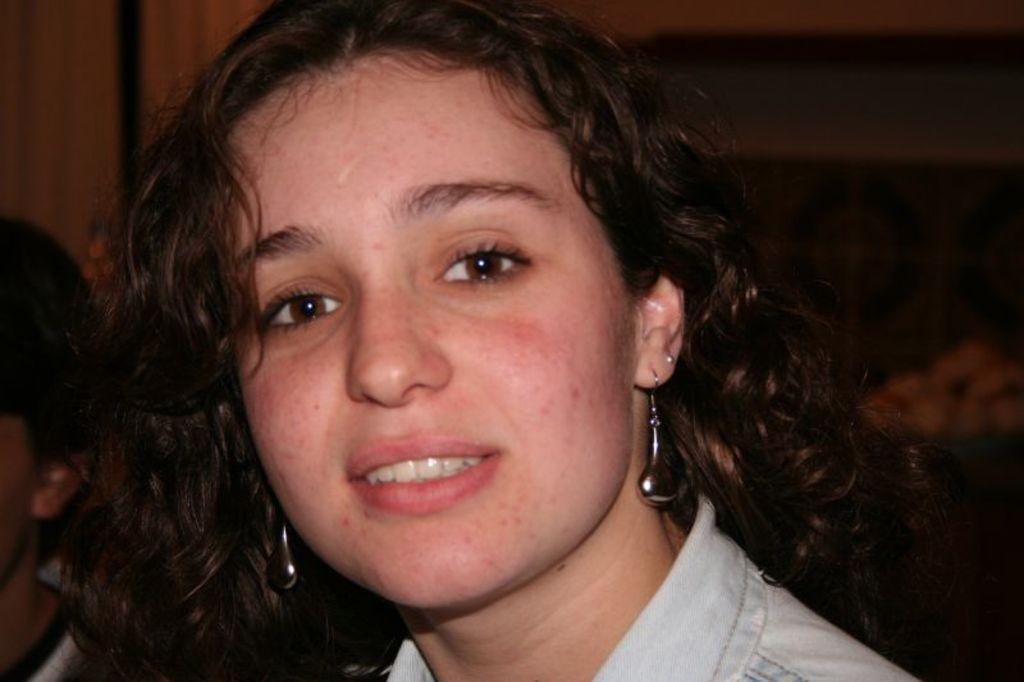In one or two sentences, can you explain what this image depicts? In this image, I can see the woman smiling. The background looks blurry. On the left corner of the image, there is another person. 